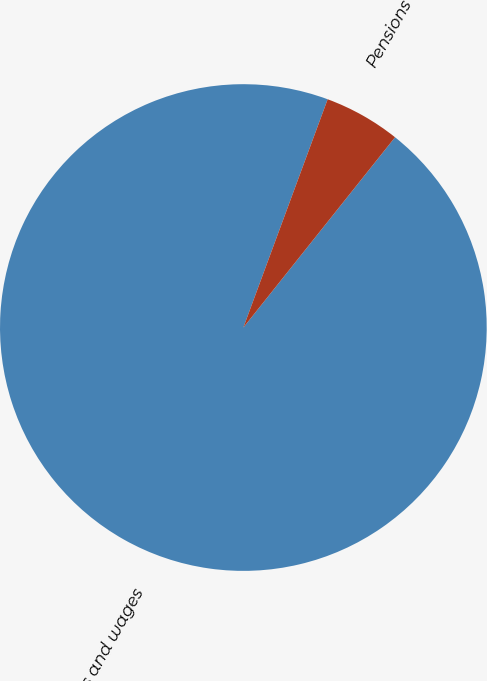<chart> <loc_0><loc_0><loc_500><loc_500><pie_chart><fcel>Salaries and wages<fcel>Pensions<nl><fcel>94.92%<fcel>5.08%<nl></chart> 